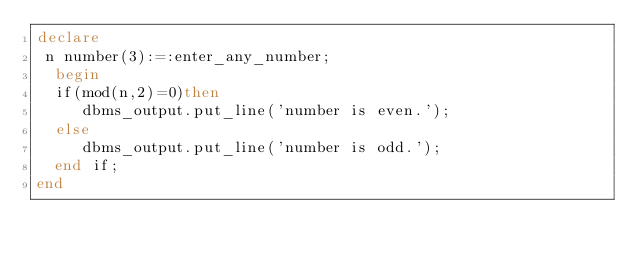<code> <loc_0><loc_0><loc_500><loc_500><_SQL_>declare
 n number(3):=:enter_any_number;
  begin
  if(mod(n,2)=0)then
     dbms_output.put_line('number is even.');
  else
     dbms_output.put_line('number is odd.');
  end if;
end </code> 